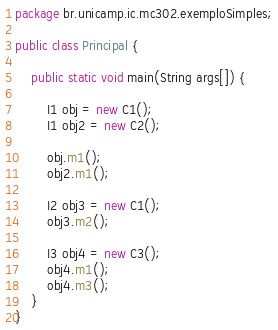Convert code to text. <code><loc_0><loc_0><loc_500><loc_500><_Java_>package br.unicamp.ic.mc302.exemploSimples;

public class Principal {

	public static void main(String args[]) {

		I1 obj = new C1();
		I1 obj2 = new C2();
		
		obj.m1();
		obj2.m1();
		
		I2 obj3 = new C1();	
		obj3.m2();
	
		I3 obj4 = new C3();
		obj4.m1();
		obj4.m3();
	}
}</code> 